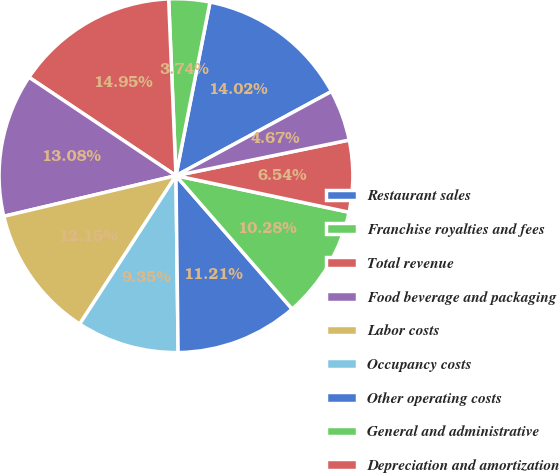<chart> <loc_0><loc_0><loc_500><loc_500><pie_chart><fcel>Restaurant sales<fcel>Franchise royalties and fees<fcel>Total revenue<fcel>Food beverage and packaging<fcel>Labor costs<fcel>Occupancy costs<fcel>Other operating costs<fcel>General and administrative<fcel>Depreciation and amortization<fcel>Pre-opening costs<nl><fcel>14.02%<fcel>3.74%<fcel>14.95%<fcel>13.08%<fcel>12.15%<fcel>9.35%<fcel>11.21%<fcel>10.28%<fcel>6.54%<fcel>4.67%<nl></chart> 